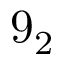Convert formula to latex. <formula><loc_0><loc_0><loc_500><loc_500>9 _ { 2 }</formula> 